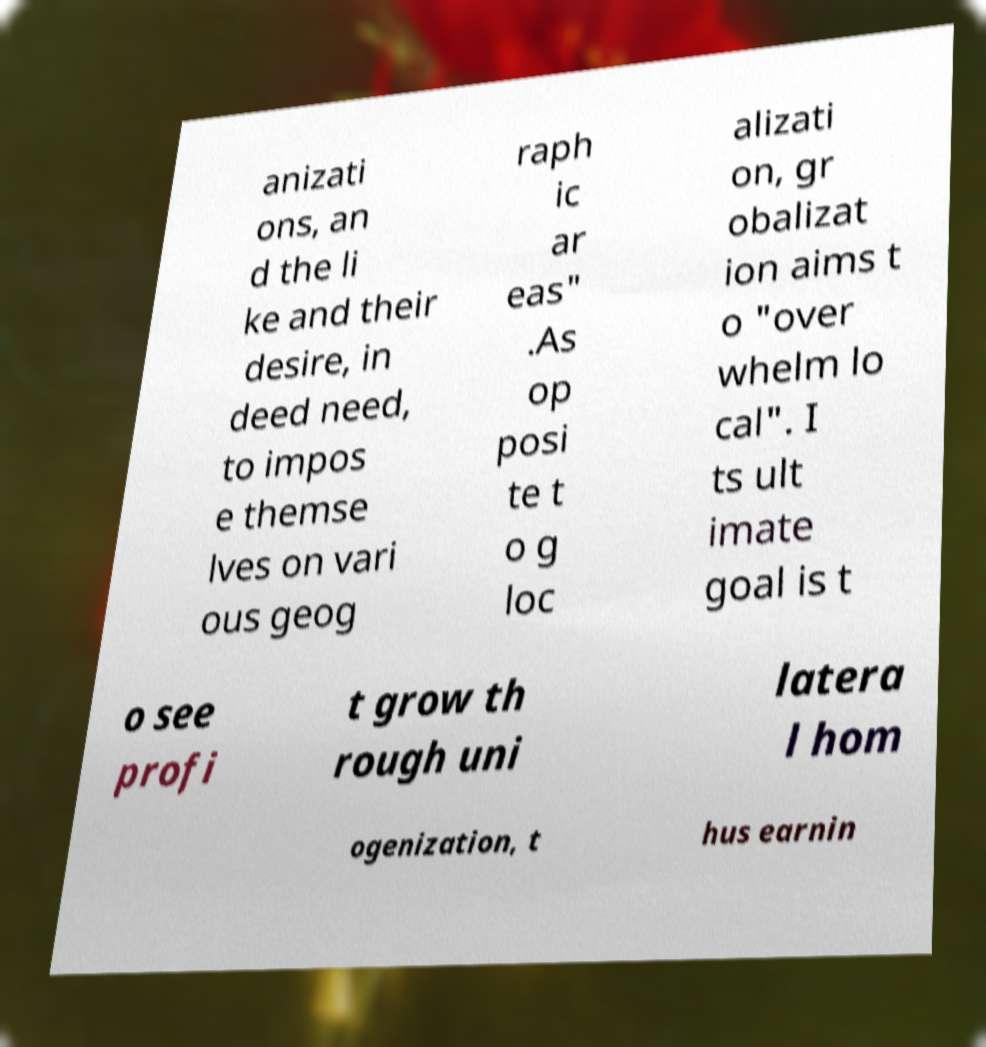For documentation purposes, I need the text within this image transcribed. Could you provide that? anizati ons, an d the li ke and their desire, in deed need, to impos e themse lves on vari ous geog raph ic ar eas" .As op posi te t o g loc alizati on, gr obalizat ion aims t o "over whelm lo cal". I ts ult imate goal is t o see profi t grow th rough uni latera l hom ogenization, t hus earnin 